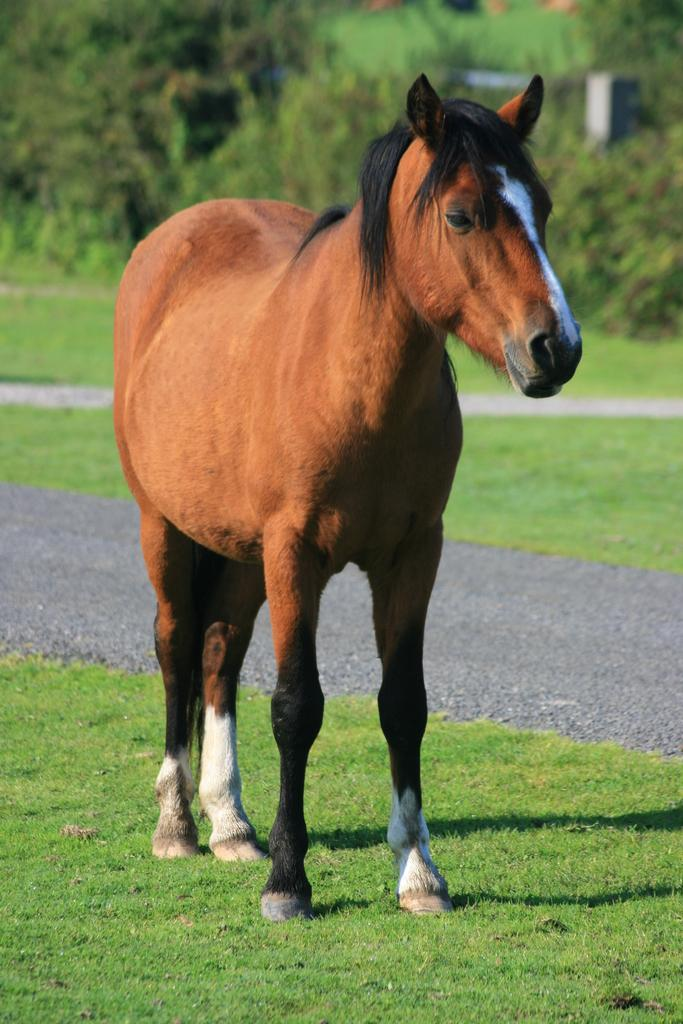What animal is present in the image? There is a horse in the image. What type of vegetation can be seen at the bottom of the image? There is grass at the bottom of the image. What other natural elements are visible in the image? There are trees visible in the image. How many icicles are hanging from the horse's mane in the image? There are no icicles present in the image, as it features a horse in a natural setting with grass and trees. 